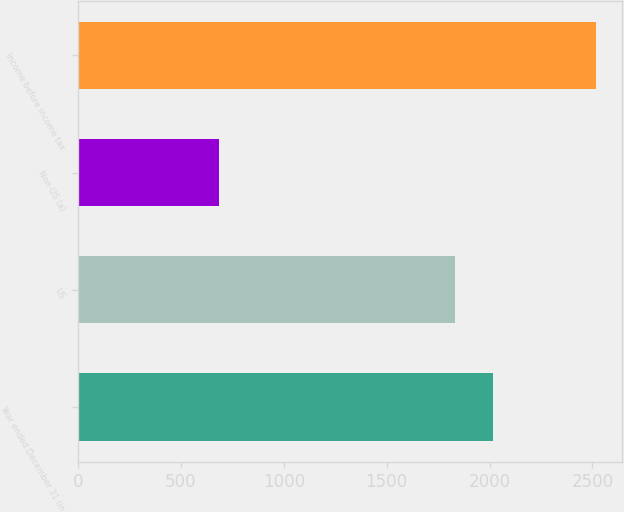Convert chart. <chart><loc_0><loc_0><loc_500><loc_500><bar_chart><fcel>Year ended December 31 (in<fcel>US<fcel>Non-US (a)<fcel>Income before income tax<nl><fcel>2017.4<fcel>1834<fcel>685<fcel>2519<nl></chart> 